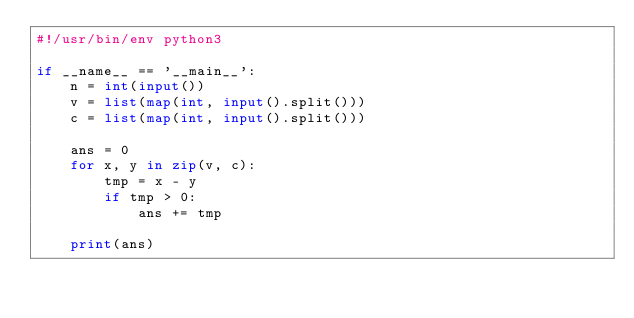Convert code to text. <code><loc_0><loc_0><loc_500><loc_500><_Python_>#!/usr/bin/env python3

if __name__ == '__main__':
    n = int(input())
    v = list(map(int, input().split()))
    c = list(map(int, input().split()))
    
    ans = 0
    for x, y in zip(v, c):
        tmp = x - y
        if tmp > 0:
            ans += tmp

    print(ans)</code> 